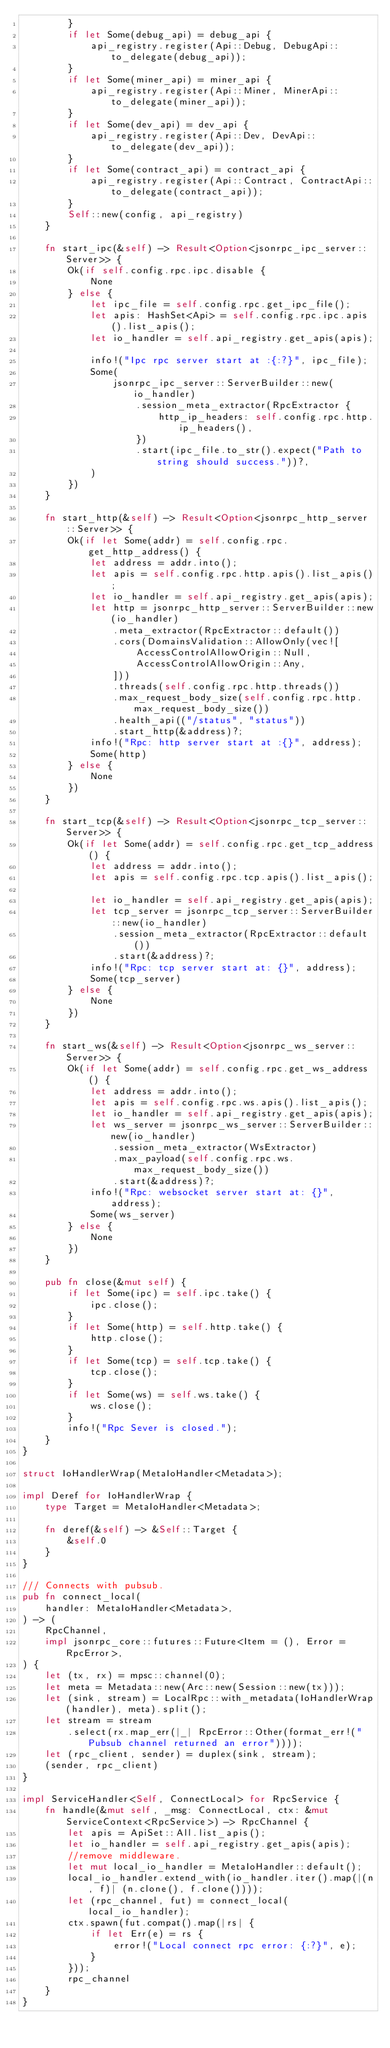Convert code to text. <code><loc_0><loc_0><loc_500><loc_500><_Rust_>        }
        if let Some(debug_api) = debug_api {
            api_registry.register(Api::Debug, DebugApi::to_delegate(debug_api));
        }
        if let Some(miner_api) = miner_api {
            api_registry.register(Api::Miner, MinerApi::to_delegate(miner_api));
        }
        if let Some(dev_api) = dev_api {
            api_registry.register(Api::Dev, DevApi::to_delegate(dev_api));
        }
        if let Some(contract_api) = contract_api {
            api_registry.register(Api::Contract, ContractApi::to_delegate(contract_api));
        }
        Self::new(config, api_registry)
    }

    fn start_ipc(&self) -> Result<Option<jsonrpc_ipc_server::Server>> {
        Ok(if self.config.rpc.ipc.disable {
            None
        } else {
            let ipc_file = self.config.rpc.get_ipc_file();
            let apis: HashSet<Api> = self.config.rpc.ipc.apis().list_apis();
            let io_handler = self.api_registry.get_apis(apis);

            info!("Ipc rpc server start at :{:?}", ipc_file);
            Some(
                jsonrpc_ipc_server::ServerBuilder::new(io_handler)
                    .session_meta_extractor(RpcExtractor {
                        http_ip_headers: self.config.rpc.http.ip_headers(),
                    })
                    .start(ipc_file.to_str().expect("Path to string should success."))?,
            )
        })
    }

    fn start_http(&self) -> Result<Option<jsonrpc_http_server::Server>> {
        Ok(if let Some(addr) = self.config.rpc.get_http_address() {
            let address = addr.into();
            let apis = self.config.rpc.http.apis().list_apis();
            let io_handler = self.api_registry.get_apis(apis);
            let http = jsonrpc_http_server::ServerBuilder::new(io_handler)
                .meta_extractor(RpcExtractor::default())
                .cors(DomainsValidation::AllowOnly(vec![
                    AccessControlAllowOrigin::Null,
                    AccessControlAllowOrigin::Any,
                ]))
                .threads(self.config.rpc.http.threads())
                .max_request_body_size(self.config.rpc.http.max_request_body_size())
                .health_api(("/status", "status"))
                .start_http(&address)?;
            info!("Rpc: http server start at :{}", address);
            Some(http)
        } else {
            None
        })
    }

    fn start_tcp(&self) -> Result<Option<jsonrpc_tcp_server::Server>> {
        Ok(if let Some(addr) = self.config.rpc.get_tcp_address() {
            let address = addr.into();
            let apis = self.config.rpc.tcp.apis().list_apis();

            let io_handler = self.api_registry.get_apis(apis);
            let tcp_server = jsonrpc_tcp_server::ServerBuilder::new(io_handler)
                .session_meta_extractor(RpcExtractor::default())
                .start(&address)?;
            info!("Rpc: tcp server start at: {}", address);
            Some(tcp_server)
        } else {
            None
        })
    }

    fn start_ws(&self) -> Result<Option<jsonrpc_ws_server::Server>> {
        Ok(if let Some(addr) = self.config.rpc.get_ws_address() {
            let address = addr.into();
            let apis = self.config.rpc.ws.apis().list_apis();
            let io_handler = self.api_registry.get_apis(apis);
            let ws_server = jsonrpc_ws_server::ServerBuilder::new(io_handler)
                .session_meta_extractor(WsExtractor)
                .max_payload(self.config.rpc.ws.max_request_body_size())
                .start(&address)?;
            info!("Rpc: websocket server start at: {}", address);
            Some(ws_server)
        } else {
            None
        })
    }

    pub fn close(&mut self) {
        if let Some(ipc) = self.ipc.take() {
            ipc.close();
        }
        if let Some(http) = self.http.take() {
            http.close();
        }
        if let Some(tcp) = self.tcp.take() {
            tcp.close();
        }
        if let Some(ws) = self.ws.take() {
            ws.close();
        }
        info!("Rpc Sever is closed.");
    }
}

struct IoHandlerWrap(MetaIoHandler<Metadata>);

impl Deref for IoHandlerWrap {
    type Target = MetaIoHandler<Metadata>;

    fn deref(&self) -> &Self::Target {
        &self.0
    }
}

/// Connects with pubsub.
pub fn connect_local(
    handler: MetaIoHandler<Metadata>,
) -> (
    RpcChannel,
    impl jsonrpc_core::futures::Future<Item = (), Error = RpcError>,
) {
    let (tx, rx) = mpsc::channel(0);
    let meta = Metadata::new(Arc::new(Session::new(tx)));
    let (sink, stream) = LocalRpc::with_metadata(IoHandlerWrap(handler), meta).split();
    let stream = stream
        .select(rx.map_err(|_| RpcError::Other(format_err!("Pubsub channel returned an error"))));
    let (rpc_client, sender) = duplex(sink, stream);
    (sender, rpc_client)
}

impl ServiceHandler<Self, ConnectLocal> for RpcService {
    fn handle(&mut self, _msg: ConnectLocal, ctx: &mut ServiceContext<RpcService>) -> RpcChannel {
        let apis = ApiSet::All.list_apis();
        let io_handler = self.api_registry.get_apis(apis);
        //remove middleware.
        let mut local_io_handler = MetaIoHandler::default();
        local_io_handler.extend_with(io_handler.iter().map(|(n, f)| (n.clone(), f.clone())));
        let (rpc_channel, fut) = connect_local(local_io_handler);
        ctx.spawn(fut.compat().map(|rs| {
            if let Err(e) = rs {
                error!("Local connect rpc error: {:?}", e);
            }
        }));
        rpc_channel
    }
}
</code> 